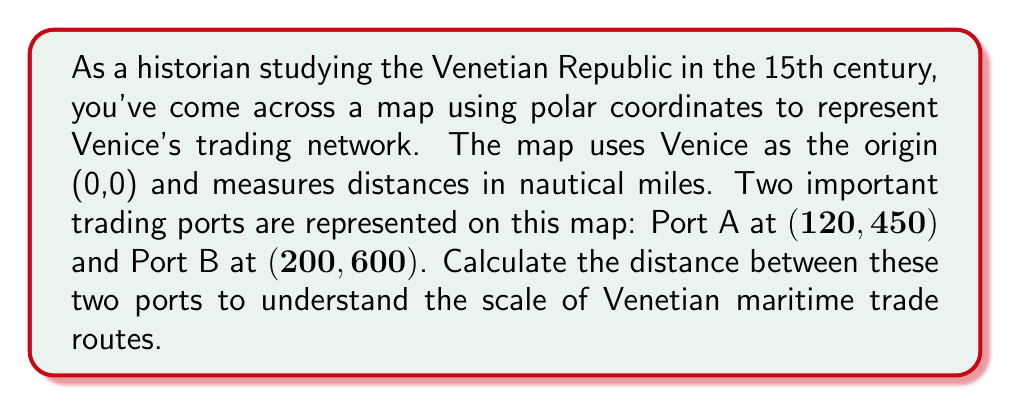Show me your answer to this math problem. To solve this problem, we'll use the law of cosines for polar coordinates. The steps are as follows:

1) Let's denote the distance between the two ports as $d$. We'll use the formula:

   $$d^2 = r_1^2 + r_2^2 - 2r_1r_2\cos(\theta_2 - \theta_1)$$

   Where $r_1$ and $\theta_1$ are the coordinates of Port A, and $r_2$ and $\theta_2$ are the coordinates of Port B.

2) We have:
   $r_1 = 450$, $\theta_1 = 120°$
   $r_2 = 600$, $\theta_2 = 200°$

3) Plugging these into our formula:

   $$d^2 = 450^2 + 600^2 - 2(450)(600)\cos(200° - 120°)$$

4) Simplify:
   $$d^2 = 202,500 + 360,000 - 540,000\cos(80°)$$

5) $\cos(80°) \approx 0.1736$, so:

   $$d^2 = 202,500 + 360,000 - 540,000(0.1736)$$
   $$d^2 = 202,500 + 360,000 - 93,744$$
   $$d^2 = 468,756$$

6) Take the square root of both sides:

   $$d = \sqrt{468,756} \approx 684.66$$

Therefore, the distance between the two ports is approximately 684.66 nautical miles.

This calculation demonstrates the vast scale of Venetian maritime trade in the 15th century, providing a quantitative perspective on the extent of Venice's commercial network.
Answer: The distance between Port A and Port B is approximately 684.66 nautical miles. 